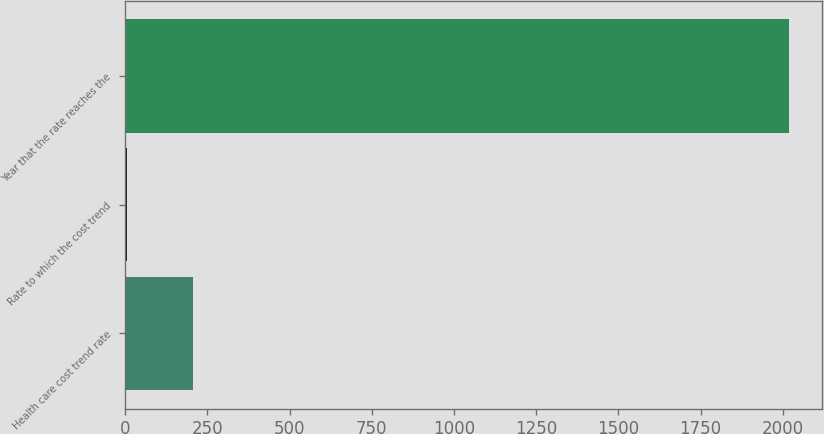Convert chart. <chart><loc_0><loc_0><loc_500><loc_500><bar_chart><fcel>Health care cost trend rate<fcel>Rate to which the cost trend<fcel>Year that the rate reaches the<nl><fcel>205.85<fcel>4.5<fcel>2018<nl></chart> 